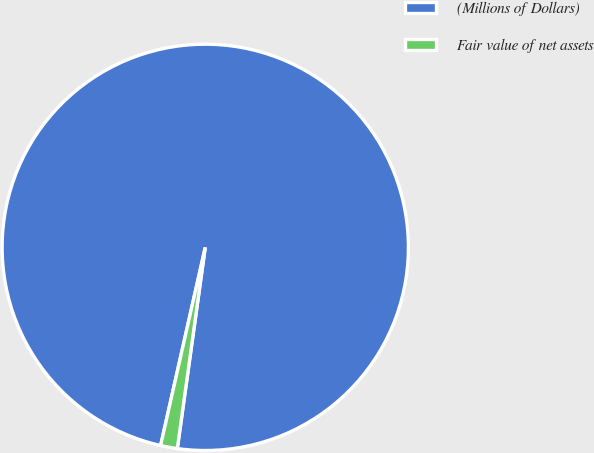Convert chart to OTSL. <chart><loc_0><loc_0><loc_500><loc_500><pie_chart><fcel>(Millions of Dollars)<fcel>Fair value of net assets<nl><fcel>98.67%<fcel>1.33%<nl></chart> 